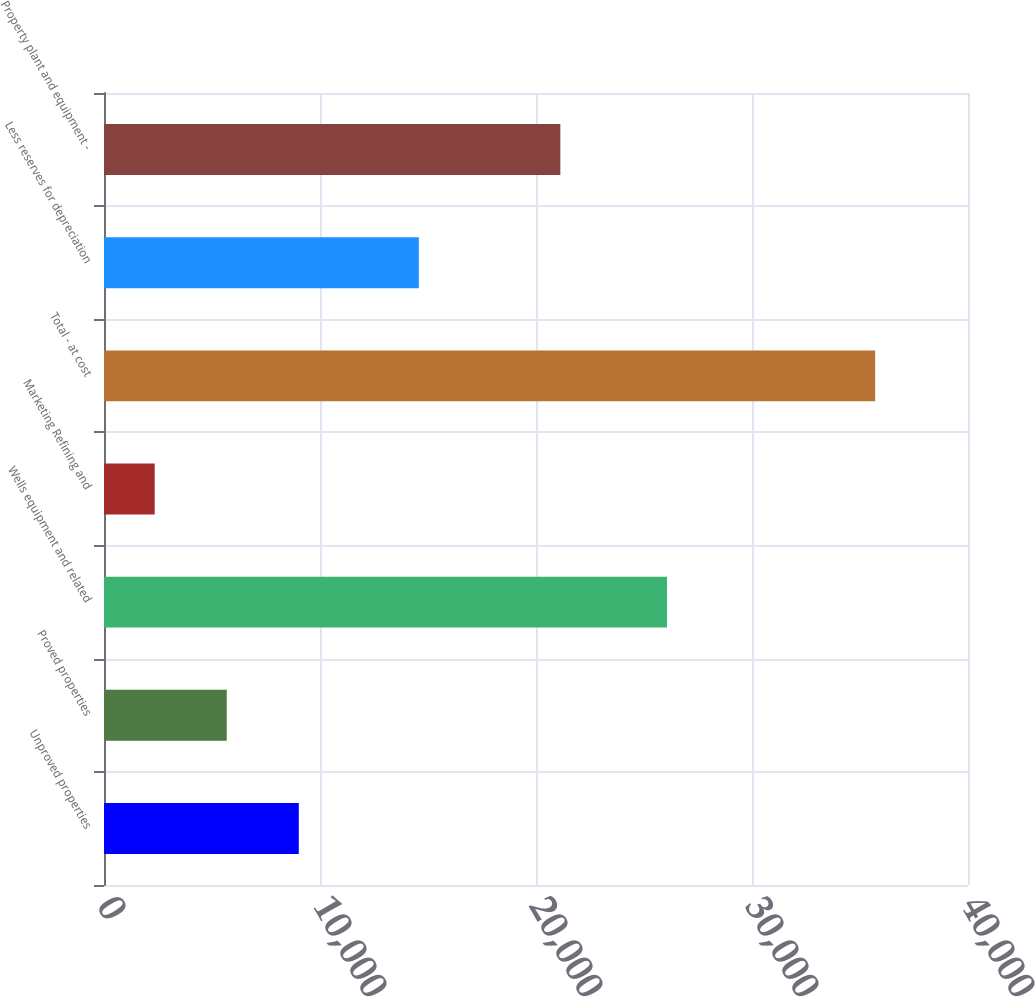Convert chart. <chart><loc_0><loc_0><loc_500><loc_500><bar_chart><fcel>Unproved properties<fcel>Proved properties<fcel>Wells equipment and related<fcel>Marketing Refining and<fcel>Total - at cost<fcel>Less reserves for depreciation<fcel>Property plant and equipment -<nl><fcel>9018.2<fcel>5682.6<fcel>26064<fcel>2347<fcel>35703<fcel>14576<fcel>21127<nl></chart> 